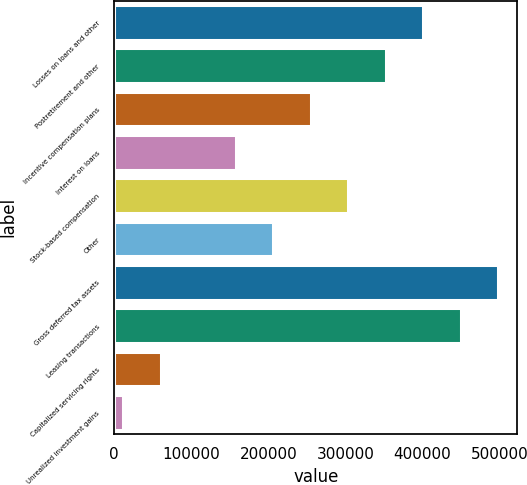Convert chart to OTSL. <chart><loc_0><loc_0><loc_500><loc_500><bar_chart><fcel>Losses on loans and other<fcel>Postretirement and other<fcel>Incentive compensation plans<fcel>Interest on loans<fcel>Stock-based compensation<fcel>Other<fcel>Gross deferred tax assets<fcel>Leasing transactions<fcel>Capitalized servicing rights<fcel>Unrealized investment gains<nl><fcel>401130<fcel>352457<fcel>255112<fcel>157766<fcel>303784<fcel>206439<fcel>498475<fcel>449802<fcel>60420.7<fcel>11748<nl></chart> 